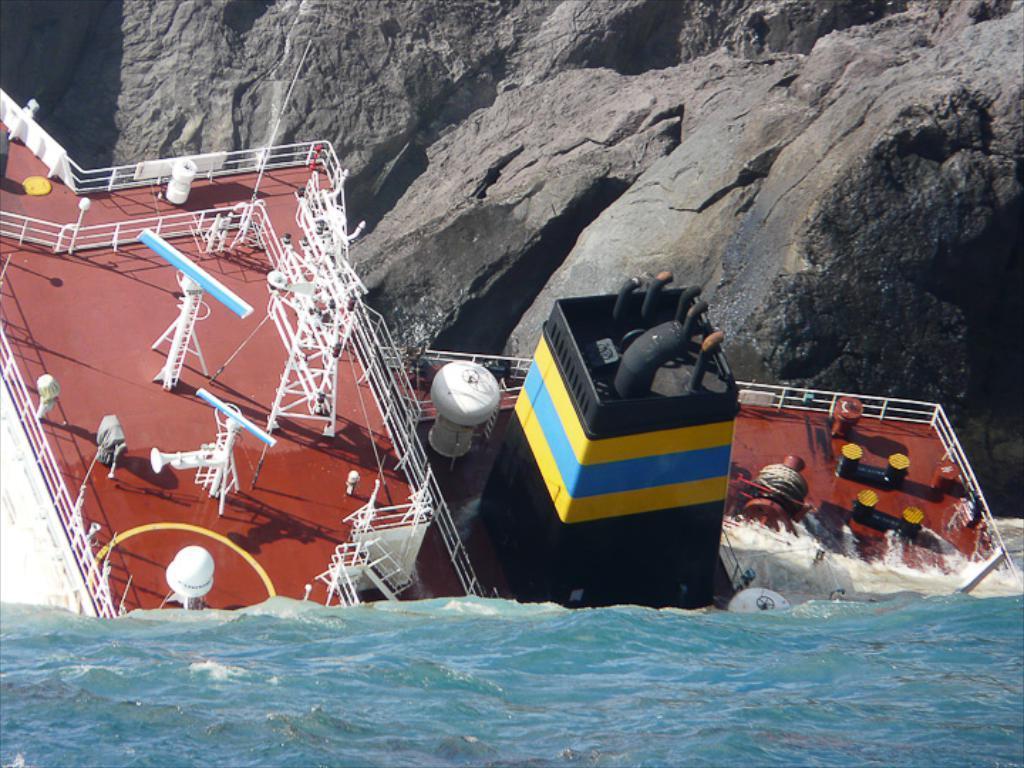Can you describe this image briefly? In the foreground of the picture there is water. In the center of the picture there is a ship drowning. At the top, it is rock. It is a sunny day. 